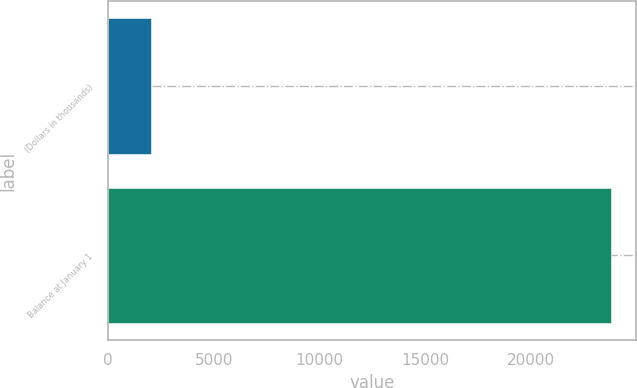Convert chart to OTSL. <chart><loc_0><loc_0><loc_500><loc_500><bar_chart><fcel>(Dollars in thousands)<fcel>Balance at January 1<nl><fcel>2011<fcel>23773<nl></chart> 